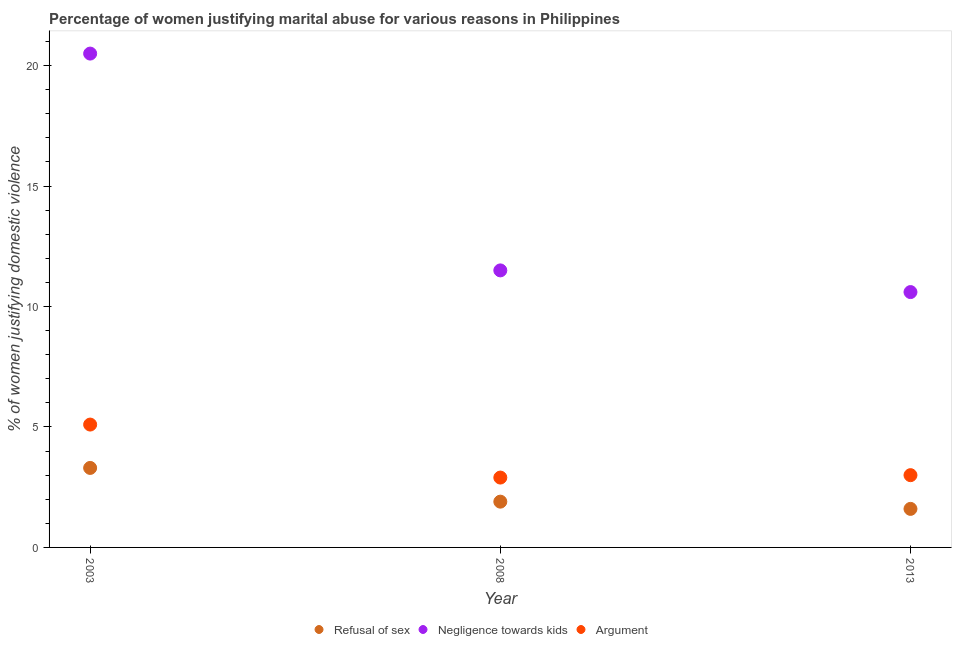Is the number of dotlines equal to the number of legend labels?
Offer a terse response. Yes. What is the percentage of women justifying domestic violence due to negligence towards kids in 2003?
Offer a very short reply. 20.5. Across all years, what is the minimum percentage of women justifying domestic violence due to arguments?
Your answer should be compact. 2.9. What is the total percentage of women justifying domestic violence due to refusal of sex in the graph?
Offer a very short reply. 6.8. What is the difference between the percentage of women justifying domestic violence due to arguments in 2003 and that in 2013?
Keep it short and to the point. 2.1. What is the average percentage of women justifying domestic violence due to refusal of sex per year?
Make the answer very short. 2.27. What is the ratio of the percentage of women justifying domestic violence due to negligence towards kids in 2003 to that in 2008?
Your answer should be very brief. 1.78. What is the difference between the highest and the second highest percentage of women justifying domestic violence due to refusal of sex?
Ensure brevity in your answer.  1.4. What is the difference between the highest and the lowest percentage of women justifying domestic violence due to refusal of sex?
Ensure brevity in your answer.  1.7. In how many years, is the percentage of women justifying domestic violence due to negligence towards kids greater than the average percentage of women justifying domestic violence due to negligence towards kids taken over all years?
Offer a terse response. 1. Is the sum of the percentage of women justifying domestic violence due to arguments in 2003 and 2013 greater than the maximum percentage of women justifying domestic violence due to negligence towards kids across all years?
Your answer should be compact. No. Is it the case that in every year, the sum of the percentage of women justifying domestic violence due to refusal of sex and percentage of women justifying domestic violence due to negligence towards kids is greater than the percentage of women justifying domestic violence due to arguments?
Provide a short and direct response. Yes. Does the percentage of women justifying domestic violence due to negligence towards kids monotonically increase over the years?
Provide a succinct answer. No. Is the percentage of women justifying domestic violence due to refusal of sex strictly greater than the percentage of women justifying domestic violence due to arguments over the years?
Ensure brevity in your answer.  No. How many dotlines are there?
Provide a short and direct response. 3. Are the values on the major ticks of Y-axis written in scientific E-notation?
Make the answer very short. No. Does the graph contain any zero values?
Provide a succinct answer. No. How many legend labels are there?
Ensure brevity in your answer.  3. What is the title of the graph?
Ensure brevity in your answer.  Percentage of women justifying marital abuse for various reasons in Philippines. What is the label or title of the Y-axis?
Your answer should be very brief. % of women justifying domestic violence. What is the % of women justifying domestic violence of Refusal of sex in 2003?
Make the answer very short. 3.3. What is the % of women justifying domestic violence in Negligence towards kids in 2003?
Your answer should be very brief. 20.5. What is the % of women justifying domestic violence of Refusal of sex in 2008?
Ensure brevity in your answer.  1.9. What is the % of women justifying domestic violence of Argument in 2008?
Offer a terse response. 2.9. What is the % of women justifying domestic violence in Negligence towards kids in 2013?
Offer a very short reply. 10.6. What is the % of women justifying domestic violence of Argument in 2013?
Provide a succinct answer. 3. Across all years, what is the maximum % of women justifying domestic violence in Argument?
Your response must be concise. 5.1. Across all years, what is the minimum % of women justifying domestic violence in Refusal of sex?
Keep it short and to the point. 1.6. Across all years, what is the minimum % of women justifying domestic violence in Negligence towards kids?
Your answer should be compact. 10.6. What is the total % of women justifying domestic violence of Negligence towards kids in the graph?
Make the answer very short. 42.6. What is the difference between the % of women justifying domestic violence in Negligence towards kids in 2003 and that in 2008?
Your answer should be compact. 9. What is the difference between the % of women justifying domestic violence in Argument in 2003 and that in 2008?
Your answer should be very brief. 2.2. What is the difference between the % of women justifying domestic violence in Refusal of sex in 2003 and that in 2013?
Your response must be concise. 1.7. What is the difference between the % of women justifying domestic violence of Negligence towards kids in 2008 and that in 2013?
Ensure brevity in your answer.  0.9. What is the difference between the % of women justifying domestic violence of Argument in 2008 and that in 2013?
Your response must be concise. -0.1. What is the difference between the % of women justifying domestic violence in Refusal of sex in 2003 and the % of women justifying domestic violence in Argument in 2013?
Your answer should be very brief. 0.3. What is the difference between the % of women justifying domestic violence of Negligence towards kids in 2003 and the % of women justifying domestic violence of Argument in 2013?
Ensure brevity in your answer.  17.5. What is the difference between the % of women justifying domestic violence of Refusal of sex in 2008 and the % of women justifying domestic violence of Argument in 2013?
Offer a very short reply. -1.1. What is the difference between the % of women justifying domestic violence of Negligence towards kids in 2008 and the % of women justifying domestic violence of Argument in 2013?
Your answer should be compact. 8.5. What is the average % of women justifying domestic violence in Refusal of sex per year?
Offer a very short reply. 2.27. What is the average % of women justifying domestic violence of Negligence towards kids per year?
Your answer should be compact. 14.2. What is the average % of women justifying domestic violence in Argument per year?
Offer a terse response. 3.67. In the year 2003, what is the difference between the % of women justifying domestic violence of Refusal of sex and % of women justifying domestic violence of Negligence towards kids?
Your response must be concise. -17.2. In the year 2003, what is the difference between the % of women justifying domestic violence in Refusal of sex and % of women justifying domestic violence in Argument?
Provide a short and direct response. -1.8. In the year 2003, what is the difference between the % of women justifying domestic violence of Negligence towards kids and % of women justifying domestic violence of Argument?
Provide a short and direct response. 15.4. In the year 2013, what is the difference between the % of women justifying domestic violence of Negligence towards kids and % of women justifying domestic violence of Argument?
Offer a terse response. 7.6. What is the ratio of the % of women justifying domestic violence in Refusal of sex in 2003 to that in 2008?
Make the answer very short. 1.74. What is the ratio of the % of women justifying domestic violence of Negligence towards kids in 2003 to that in 2008?
Give a very brief answer. 1.78. What is the ratio of the % of women justifying domestic violence of Argument in 2003 to that in 2008?
Provide a short and direct response. 1.76. What is the ratio of the % of women justifying domestic violence in Refusal of sex in 2003 to that in 2013?
Your response must be concise. 2.06. What is the ratio of the % of women justifying domestic violence of Negligence towards kids in 2003 to that in 2013?
Give a very brief answer. 1.93. What is the ratio of the % of women justifying domestic violence of Refusal of sex in 2008 to that in 2013?
Make the answer very short. 1.19. What is the ratio of the % of women justifying domestic violence of Negligence towards kids in 2008 to that in 2013?
Make the answer very short. 1.08. What is the ratio of the % of women justifying domestic violence of Argument in 2008 to that in 2013?
Offer a terse response. 0.97. What is the difference between the highest and the second highest % of women justifying domestic violence in Negligence towards kids?
Your answer should be compact. 9. What is the difference between the highest and the second highest % of women justifying domestic violence of Argument?
Your answer should be very brief. 2.1. What is the difference between the highest and the lowest % of women justifying domestic violence of Negligence towards kids?
Offer a terse response. 9.9. What is the difference between the highest and the lowest % of women justifying domestic violence in Argument?
Provide a succinct answer. 2.2. 